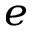Convert formula to latex. <formula><loc_0><loc_0><loc_500><loc_500>_ { e }</formula> 